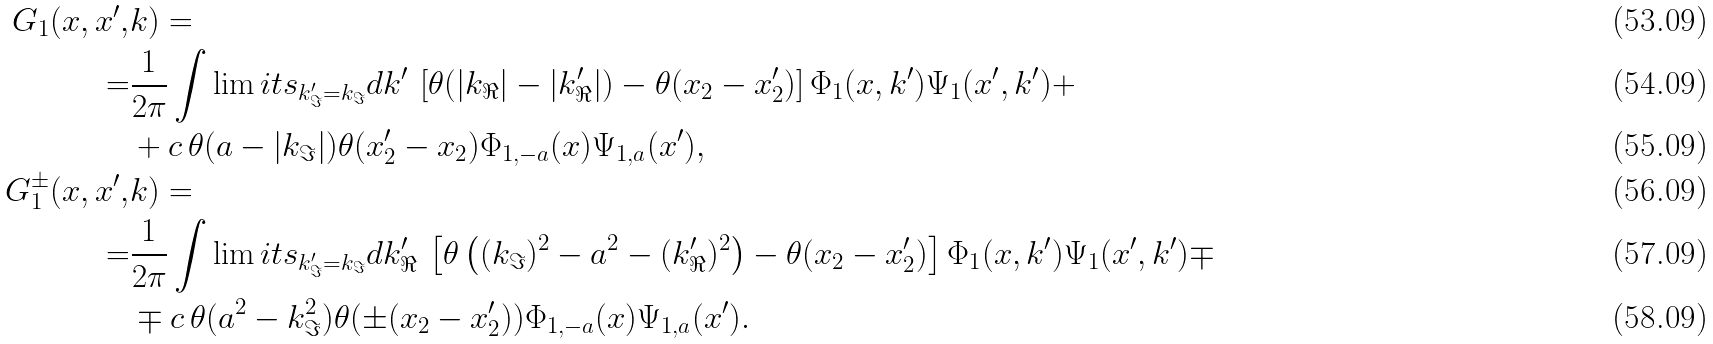Convert formula to latex. <formula><loc_0><loc_0><loc_500><loc_500>G _ { 1 } ( x , x ^ { \prime } , & k ) = \\ = & \frac { 1 } { 2 \pi } \int \lim i t s _ { k _ { \Im } ^ { \prime } = k _ { \Im } } d k ^ { \prime } \, \left [ \theta ( | k _ { \Re } | - | k _ { \Re } ^ { \prime } | ) - \theta ( x _ { 2 } - x _ { 2 } ^ { \prime } ) \right ] \Phi _ { 1 } ( x , k ^ { \prime } ) \Psi _ { 1 } ( x ^ { \prime } , k ^ { \prime } ) + \\ & + c \, \theta ( a - | k _ { \Im } | ) \theta ( x _ { 2 } ^ { \prime } - x _ { 2 } ) \Phi _ { 1 , - a } ( x ) \Psi _ { 1 , a } ( x ^ { \prime } ) , \\ G _ { 1 } ^ { \pm } ( x , x ^ { \prime } , & k ) = \\ = & \frac { 1 } { 2 \pi } \int \lim i t s _ { k _ { \Im } ^ { \prime } = k _ { \Im } } d k _ { \Re } ^ { \prime } \, \left [ \theta \left ( ( k _ { \Im } ) ^ { 2 } - a ^ { 2 } - ( k _ { \Re } ^ { \prime } ) ^ { 2 } \right ) - \theta ( x _ { 2 } - x _ { 2 } ^ { \prime } ) \right ] \Phi _ { 1 } ( x , k ^ { \prime } ) \Psi _ { 1 } ( x ^ { \prime } , k ^ { \prime } ) \mp \\ & \mp c \, \theta ( a ^ { 2 } - k _ { \Im } ^ { 2 } ) \theta ( \pm ( x _ { 2 } - x _ { 2 } ^ { \prime } ) ) \Phi _ { 1 , - a } ( x ) \Psi _ { 1 , a } ( x ^ { \prime } ) .</formula> 